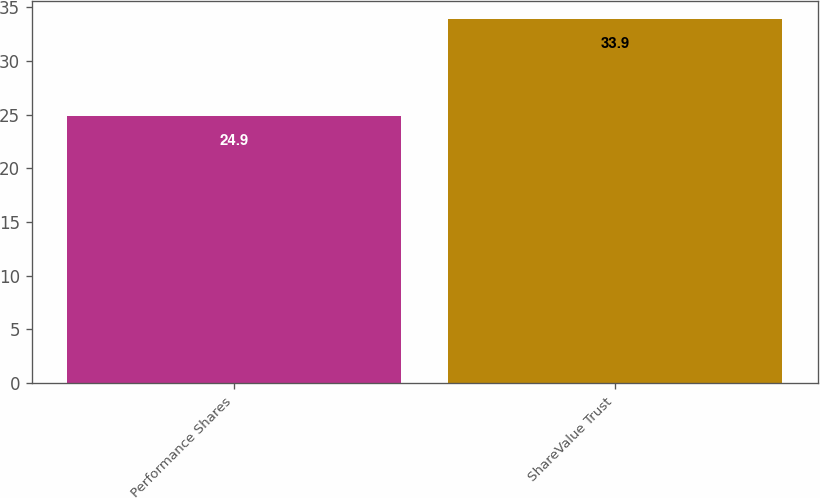Convert chart to OTSL. <chart><loc_0><loc_0><loc_500><loc_500><bar_chart><fcel>Performance Shares<fcel>ShareValue Trust<nl><fcel>24.9<fcel>33.9<nl></chart> 